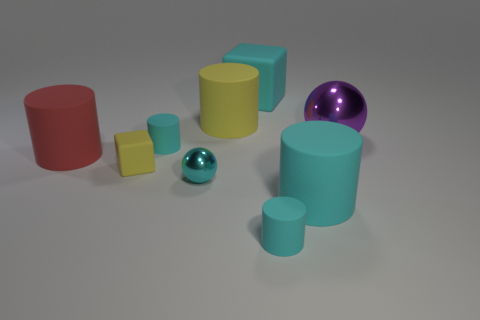Subtract all cyan cylinders. How many cylinders are left? 2 Add 1 large purple metal spheres. How many objects exist? 10 Subtract all red cylinders. How many cylinders are left? 4 Subtract all cubes. How many objects are left? 7 Subtract all purple blocks. How many cyan cylinders are left? 3 Add 7 red rubber objects. How many red rubber objects exist? 8 Subtract 1 cyan spheres. How many objects are left? 8 Subtract 2 spheres. How many spheres are left? 0 Subtract all purple cylinders. Subtract all green cubes. How many cylinders are left? 5 Subtract all large spheres. Subtract all large cyan matte things. How many objects are left? 6 